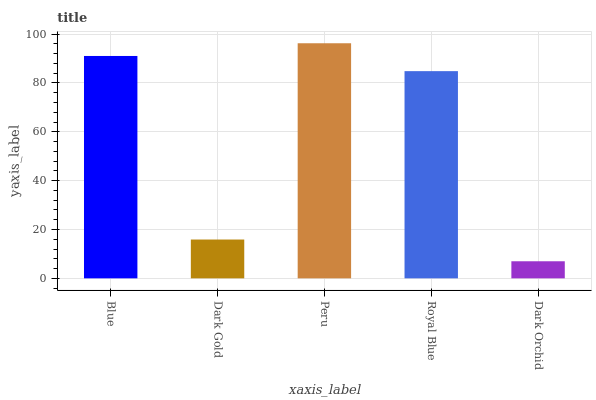Is Dark Orchid the minimum?
Answer yes or no. Yes. Is Peru the maximum?
Answer yes or no. Yes. Is Dark Gold the minimum?
Answer yes or no. No. Is Dark Gold the maximum?
Answer yes or no. No. Is Blue greater than Dark Gold?
Answer yes or no. Yes. Is Dark Gold less than Blue?
Answer yes or no. Yes. Is Dark Gold greater than Blue?
Answer yes or no. No. Is Blue less than Dark Gold?
Answer yes or no. No. Is Royal Blue the high median?
Answer yes or no. Yes. Is Royal Blue the low median?
Answer yes or no. Yes. Is Peru the high median?
Answer yes or no. No. Is Dark Orchid the low median?
Answer yes or no. No. 